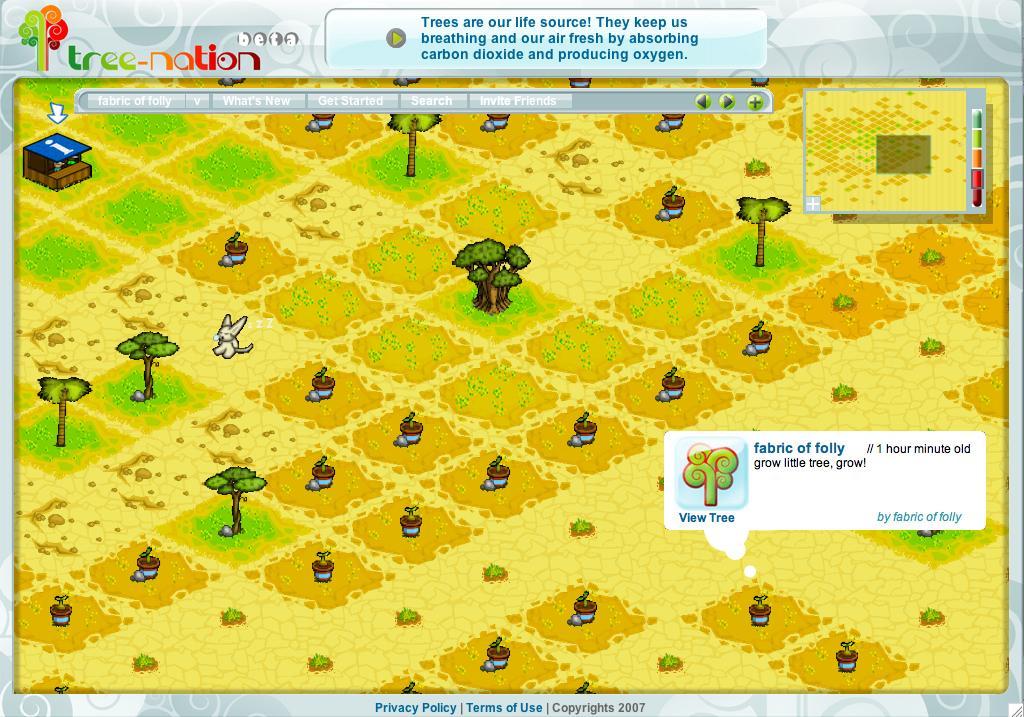How would you summarize this image in a sentence or two? In this image there is a screenshot of a game, in this there are trees, plants and an animal, at the top there is some text, in the bottom right there is some text, at the bottom there is some text. 